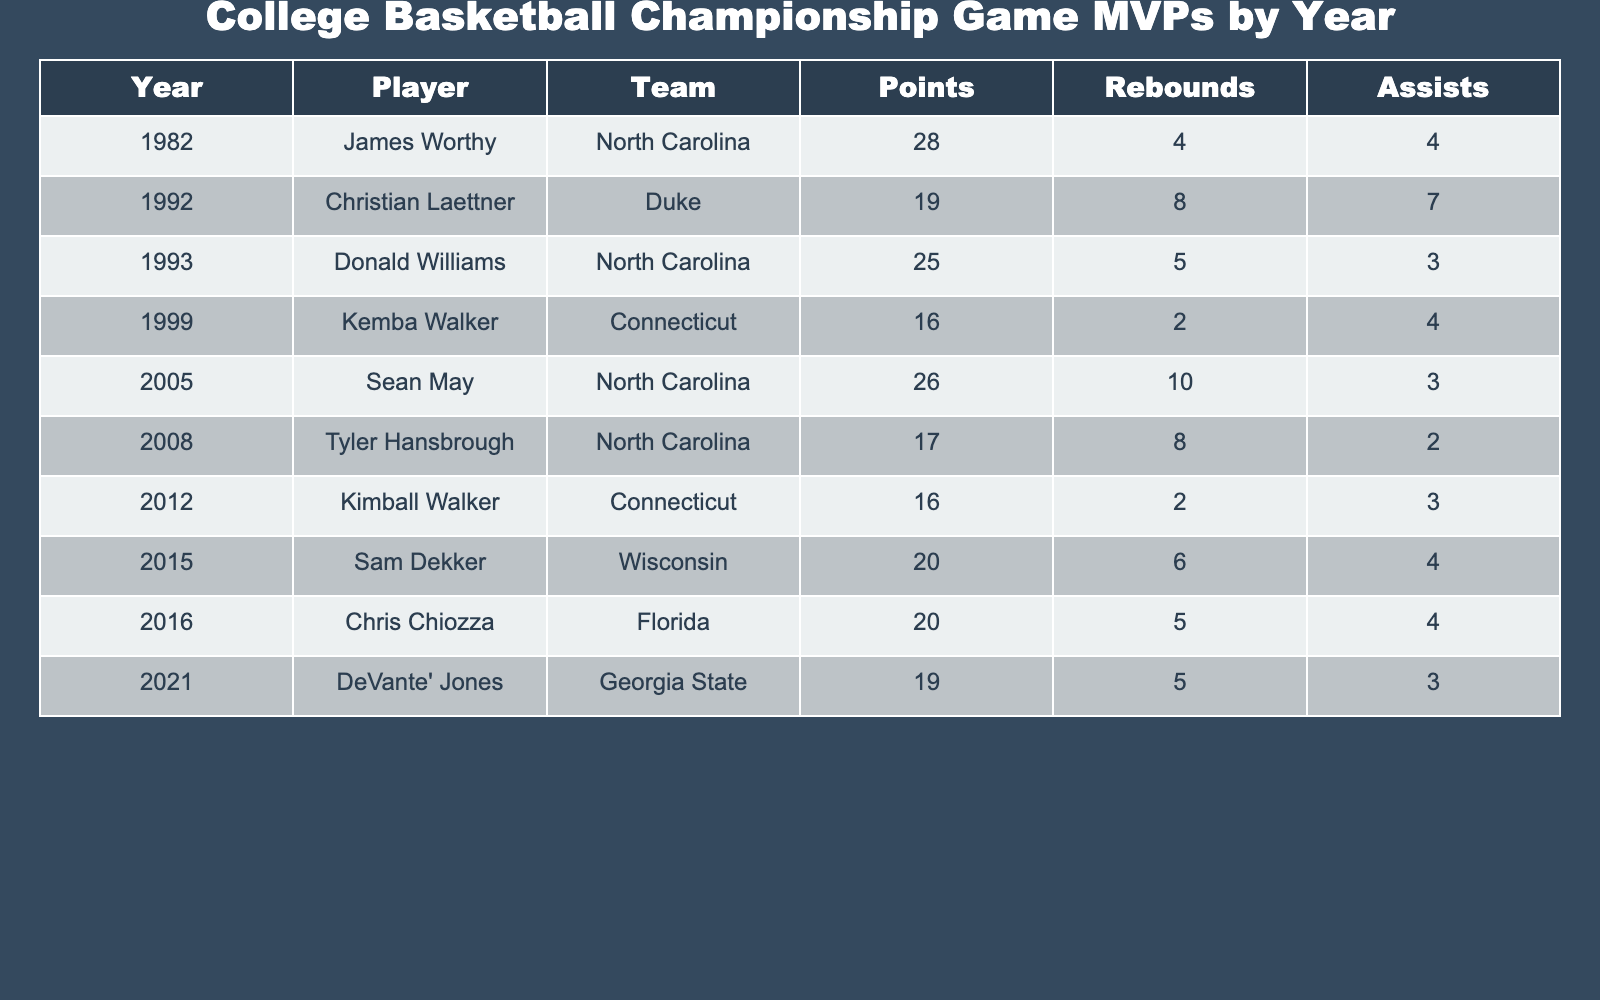What player scored the most points in a championship game? The table lists all the MVPs along with their points scored. Scanning through the “Points” column, I see that James Worthy scored 28 points in 1982, which is the highest listed.
Answer: James Worthy Which team has the most MVPs listed in the table? To determine this, I examine the “Team” column and count the occurrences of each team. North Carolina appears three times, while other teams have fewer appearances.
Answer: North Carolina What is the total number of points scored by the MVPs from Connecticut? Looking at the “Team” column for Connecticut, I find Kemba Walker with 16 points in 1999 and Kimball Walker with 16 points in 2012. Summing these gives 16 + 16 = 32.
Answer: 32 What is the average number of rebounds scored by the MVPs in the table? I sum all the rebounds from the “Rebounds” column: 4 + 8 + 5 + 2 + 10 + 8 + 2 + 6 + 5 + 5 = 55. There are 10 players, so to find the average, I divide 55 by 10, which equals 5.5.
Answer: 5.5 Did any player score fewer than 20 points and still receive MVP honors? Scanning through the “Points” column, I see both Kemba Walker (16 points) in 2011 and Kimball Walker (16 points) in 2012 scored fewer than 20 points and were named MVP, confirming the statement is true.
Answer: Yes How many MVPs scored 20 points or more? I go through the “Points” column and count the instances of players scoring 20 or more points. James Worthy, Donald Williams, Sean May, and Sam Dekker all scored 20 or more points, for a total of 5 players.
Answer: 5 Which player had the highest number of rebounds in the final game, and how many? Referencing the “Rebounds” column, Sean May scored the highest with 10 rebounds in 2005 while being the only player with that many rebounds on the list.
Answer: Sean May, 10 Was there an MVP from a team other than North Carolina or Connecticut? Examining the “Team” column reveals that the teams represented are North Carolina, Connecticut, Wisconsin, Duke, Florida, and Georgia State. The entries for Wisconsin (Sam Dekker) and Georgia State (DeVante' Jones) confirm that there are MVPs from other teams.
Answer: Yes What is the difference between the highest and lowest points scored by an MVP in the table? The highest points scored is 28 by James Worthy, while the lowest is 16 by Kemba Walker and Kimball Walker. The difference is 28 - 16 = 12.
Answer: 12 How many MVPs in total played for teams starting with the letter 'N'? Checking the “Team” column, North Carolina appears three times and is the only team starting with 'N'. Thus, there are 3 MVPs from teams starting with 'N'.
Answer: 3 